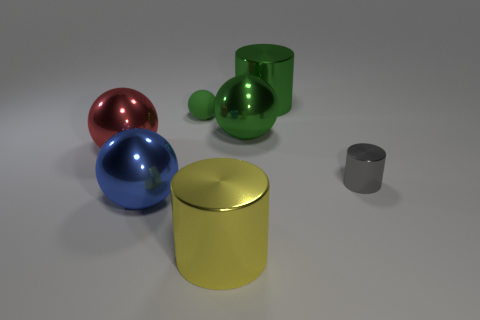There is a small thing that is left of the cylinder behind the small object to the left of the big green cylinder; what is its material?
Your answer should be very brief. Rubber. Is there a shiny thing that has the same color as the small matte thing?
Ensure brevity in your answer.  Yes. There is a large sphere behind the red metallic thing; does it have the same color as the tiny rubber sphere?
Your answer should be compact. Yes. The large metallic thing that is both in front of the green matte thing and right of the big yellow object has what shape?
Offer a very short reply. Sphere. What is the shape of the yellow thing that is made of the same material as the gray cylinder?
Provide a succinct answer. Cylinder. Are any large cyan cylinders visible?
Give a very brief answer. No. There is a large metallic sphere that is in front of the small gray shiny cylinder; is there a object to the left of it?
Your response must be concise. Yes. There is a big blue object that is the same shape as the small green object; what material is it?
Ensure brevity in your answer.  Metal. Is the number of large red shiny balls greater than the number of tiny blue cylinders?
Provide a succinct answer. Yes. Do the tiny matte sphere and the large shiny cylinder behind the tiny gray shiny object have the same color?
Keep it short and to the point. Yes. 